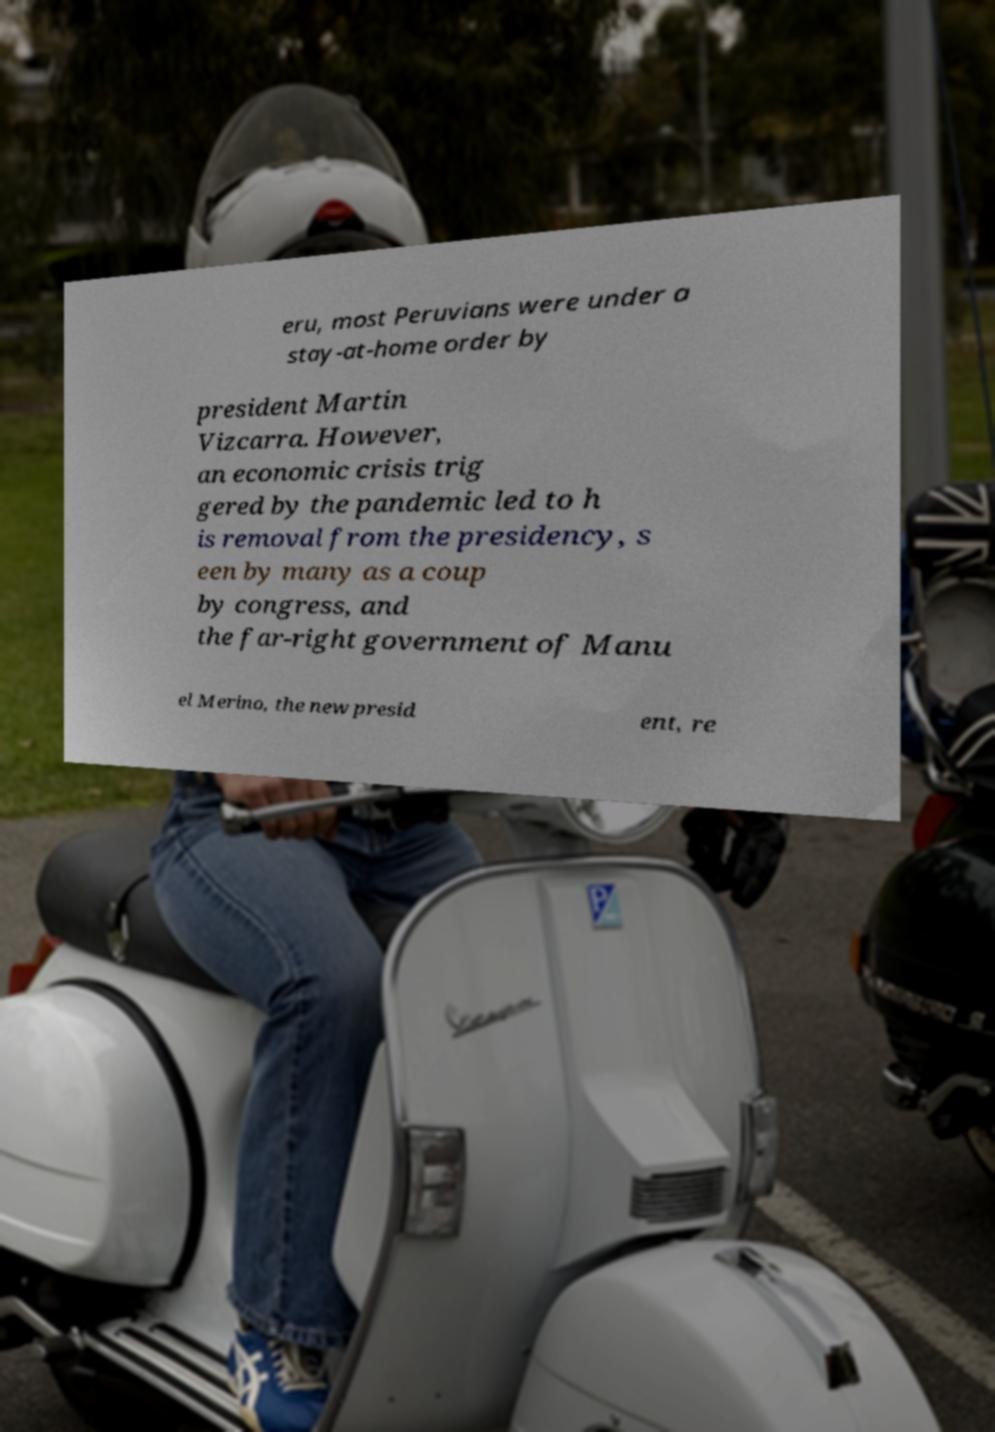There's text embedded in this image that I need extracted. Can you transcribe it verbatim? eru, most Peruvians were under a stay-at-home order by president Martin Vizcarra. However, an economic crisis trig gered by the pandemic led to h is removal from the presidency, s een by many as a coup by congress, and the far-right government of Manu el Merino, the new presid ent, re 